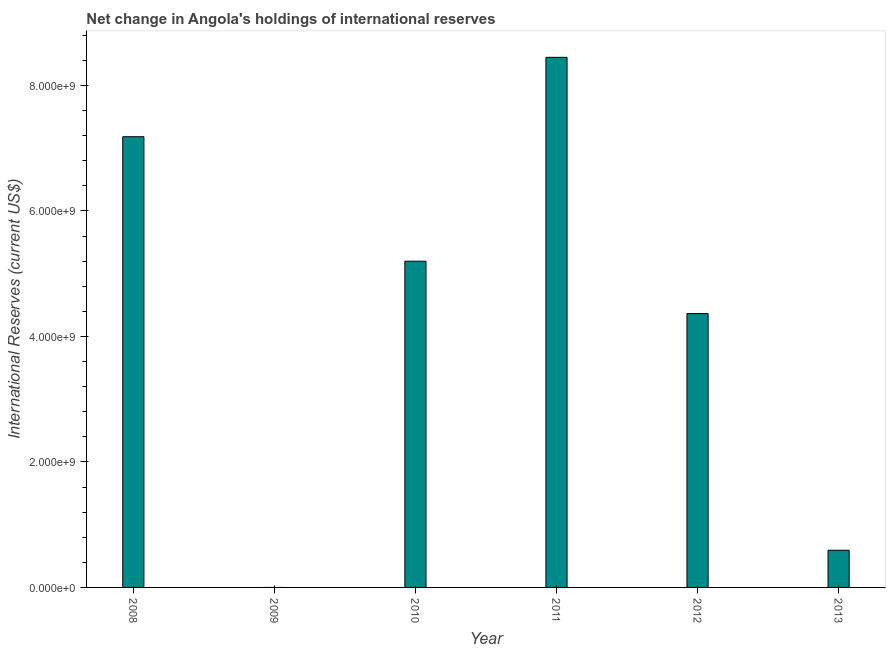What is the title of the graph?
Your answer should be compact. Net change in Angola's holdings of international reserves. What is the label or title of the X-axis?
Make the answer very short. Year. What is the label or title of the Y-axis?
Keep it short and to the point. International Reserves (current US$). What is the reserves and related items in 2009?
Make the answer very short. 0. Across all years, what is the maximum reserves and related items?
Your response must be concise. 8.45e+09. Across all years, what is the minimum reserves and related items?
Your answer should be compact. 0. What is the sum of the reserves and related items?
Give a very brief answer. 2.58e+1. What is the difference between the reserves and related items in 2010 and 2013?
Provide a short and direct response. 4.61e+09. What is the average reserves and related items per year?
Provide a succinct answer. 4.30e+09. What is the median reserves and related items?
Keep it short and to the point. 4.78e+09. What is the ratio of the reserves and related items in 2011 to that in 2013?
Your answer should be very brief. 14.26. Is the reserves and related items in 2012 less than that in 2013?
Your answer should be compact. No. What is the difference between the highest and the second highest reserves and related items?
Provide a short and direct response. 1.27e+09. What is the difference between the highest and the lowest reserves and related items?
Keep it short and to the point. 8.45e+09. In how many years, is the reserves and related items greater than the average reserves and related items taken over all years?
Make the answer very short. 4. How many bars are there?
Provide a short and direct response. 5. Are all the bars in the graph horizontal?
Ensure brevity in your answer.  No. What is the International Reserves (current US$) of 2008?
Your answer should be compact. 7.18e+09. What is the International Reserves (current US$) in 2010?
Your response must be concise. 5.20e+09. What is the International Reserves (current US$) of 2011?
Your answer should be very brief. 8.45e+09. What is the International Reserves (current US$) of 2012?
Make the answer very short. 4.36e+09. What is the International Reserves (current US$) in 2013?
Your answer should be compact. 5.93e+08. What is the difference between the International Reserves (current US$) in 2008 and 2010?
Your response must be concise. 1.98e+09. What is the difference between the International Reserves (current US$) in 2008 and 2011?
Your answer should be compact. -1.27e+09. What is the difference between the International Reserves (current US$) in 2008 and 2012?
Your response must be concise. 2.82e+09. What is the difference between the International Reserves (current US$) in 2008 and 2013?
Offer a very short reply. 6.59e+09. What is the difference between the International Reserves (current US$) in 2010 and 2011?
Your answer should be compact. -3.25e+09. What is the difference between the International Reserves (current US$) in 2010 and 2012?
Your answer should be compact. 8.35e+08. What is the difference between the International Reserves (current US$) in 2010 and 2013?
Your response must be concise. 4.61e+09. What is the difference between the International Reserves (current US$) in 2011 and 2012?
Keep it short and to the point. 4.08e+09. What is the difference between the International Reserves (current US$) in 2011 and 2013?
Your answer should be very brief. 7.86e+09. What is the difference between the International Reserves (current US$) in 2012 and 2013?
Keep it short and to the point. 3.77e+09. What is the ratio of the International Reserves (current US$) in 2008 to that in 2010?
Provide a succinct answer. 1.38. What is the ratio of the International Reserves (current US$) in 2008 to that in 2012?
Make the answer very short. 1.65. What is the ratio of the International Reserves (current US$) in 2008 to that in 2013?
Ensure brevity in your answer.  12.12. What is the ratio of the International Reserves (current US$) in 2010 to that in 2011?
Ensure brevity in your answer.  0.61. What is the ratio of the International Reserves (current US$) in 2010 to that in 2012?
Keep it short and to the point. 1.19. What is the ratio of the International Reserves (current US$) in 2010 to that in 2013?
Offer a very short reply. 8.77. What is the ratio of the International Reserves (current US$) in 2011 to that in 2012?
Offer a very short reply. 1.94. What is the ratio of the International Reserves (current US$) in 2011 to that in 2013?
Provide a succinct answer. 14.26. What is the ratio of the International Reserves (current US$) in 2012 to that in 2013?
Keep it short and to the point. 7.37. 